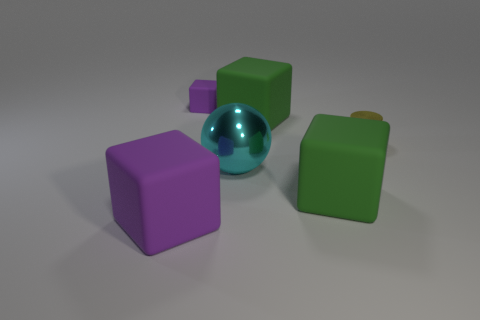Add 1 tiny purple objects. How many objects exist? 7 Subtract all cubes. How many objects are left? 2 Add 3 shiny objects. How many shiny objects exist? 5 Subtract 1 purple cubes. How many objects are left? 5 Subtract all cyan shiny spheres. Subtract all small red rubber cylinders. How many objects are left? 5 Add 2 tiny yellow shiny cylinders. How many tiny yellow shiny cylinders are left? 3 